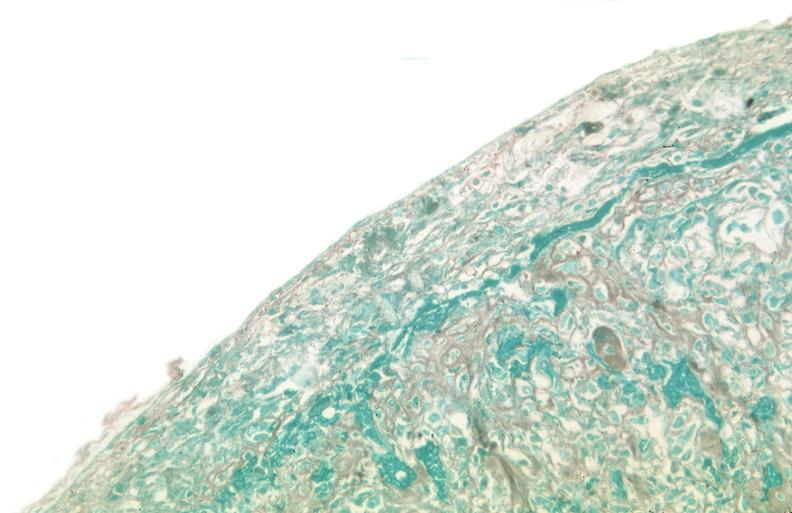does this image show pleura, talc reaction?
Answer the question using a single word or phrase. Yes 